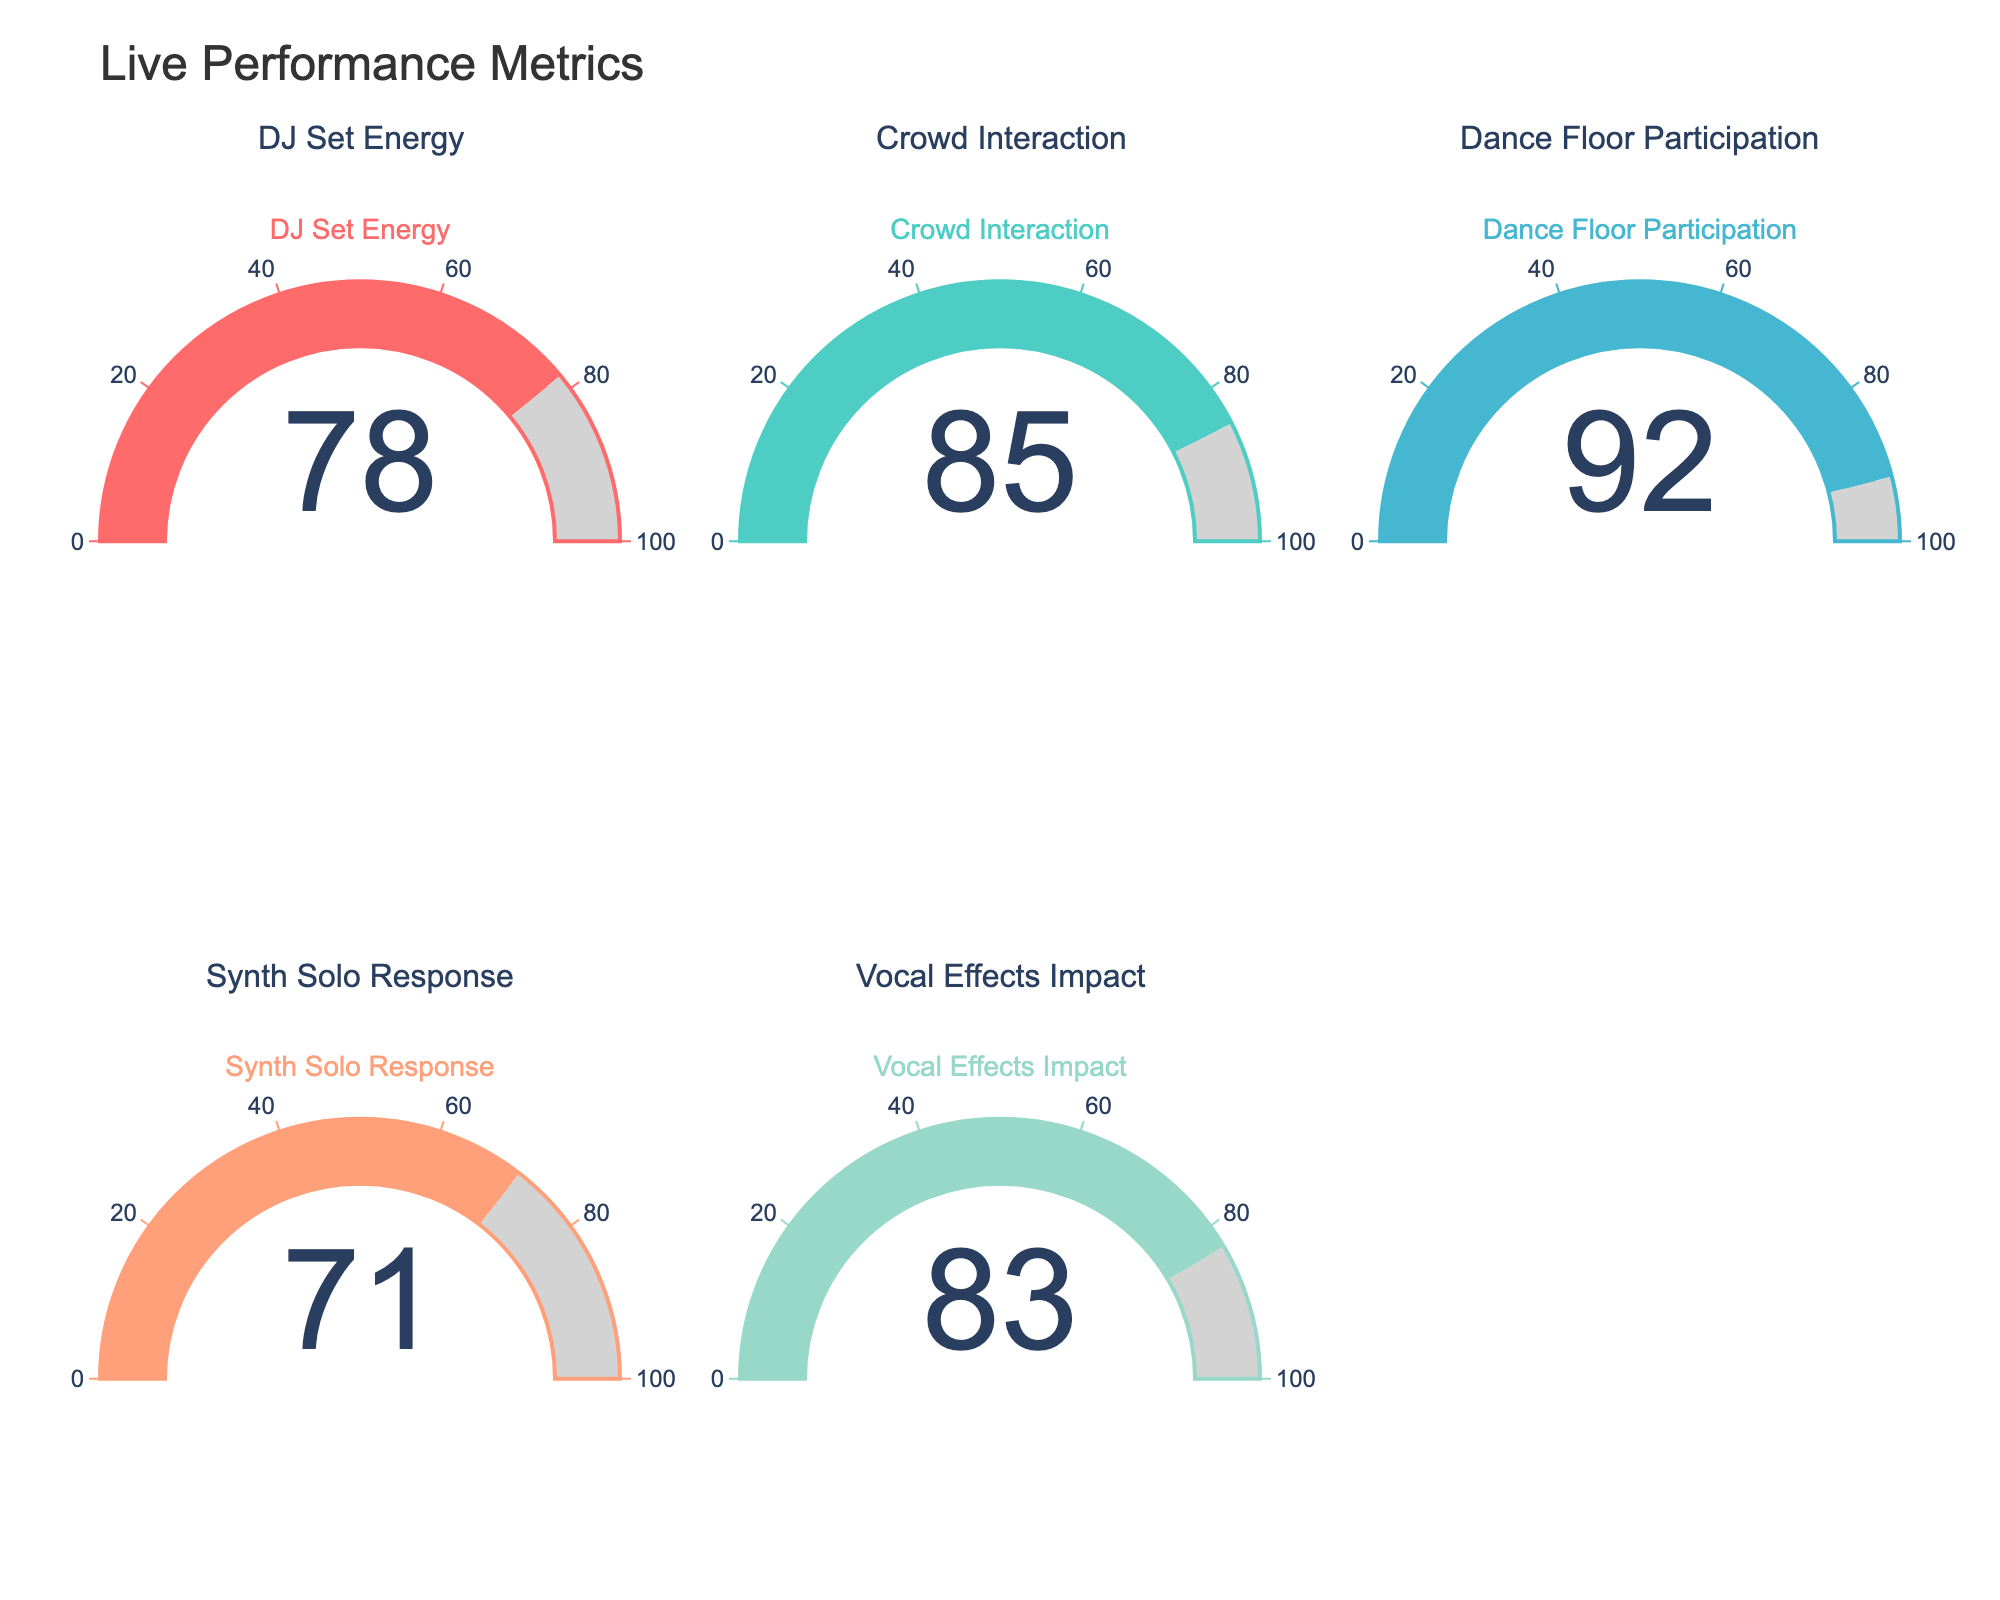What is the title of the figure? The title of the figure is displayed at the top of the plot. It summarizes the overall content of the chart.
Answer: Live Performance Metrics What is the value displayed for Dance Floor Participation? The value for Dance Floor Participation is shown on the gauge in one of the quadrants.
Answer: 92 Which metric has the highest audience engagement percentage? To determine the highest audience engagement percentage, we need to compare the values across all displayed gauges. The Dance Floor Participation has the highest percentage with a value of 92.
Answer: Dance Floor Participation Which gauge chart shows the lowest value? By examining each gauge chart, we can see that the Synth Solo Response has the lowest value.
Answer: Synth Solo Response What is the average value of all the metrics displayed? Sum all the values and divide by the number of metrics. (78 + 85 + 92 + 71 + 83) / 5 = 81.8
Answer: 81.8 How much higher is the Crowd Interaction percentage compared to the Synth Solo Response? Subtract the value of Synth Solo Response from Crowd Interaction. 85 - 71 = 14
Answer: 14 Which metric shows an engagement percentage of over 80? By looking at each gauge, we can see that the metrics with values over 80 are Crowd Interaction, Dance Floor Participation, and Vocal Effects Impact.
Answer: Crowd Interaction, Dance Floor Participation, Vocal Effects Impact Is the DJ Set Energy percentage greater than or less than the Vocal Effects Impact percentage? By comparing the two values, DJ Set Energy is 78, and Vocal Effects Impact is 83. Hence, DJ Set Energy is less than Vocal Effects Impact.
Answer: Less than Arrange the metrics from highest to lowest percentage. By sorting the values from highest to lowest: Dance Floor Participation (92), Crowd Interaction (85), Vocal Effects Impact (83), DJ Set Energy (78), Synth Solo Response (71).
Answer: Dance Floor Participation, Crowd Interaction, Vocal Effects Impact, DJ Set Energy, Synth Solo Response What is the difference between the highest and lowest engagement percentage metrics? Subtract the lowest value (Synth Solo Response, 71) from the highest value (Dance Floor Participation, 92). 92 - 71 = 21
Answer: 21 